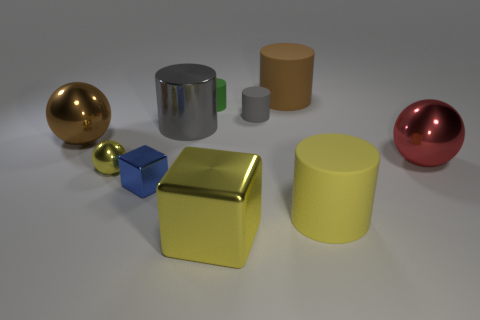Is the number of yellow metallic blocks that are to the left of the tiny yellow sphere greater than the number of brown objects that are behind the gray shiny cylinder?
Provide a short and direct response. No. Does the big gray cylinder have the same material as the large yellow cylinder?
Your answer should be very brief. No. There is a tiny rubber object on the right side of the large block; what number of gray rubber things are left of it?
Your answer should be very brief. 0. Do the large matte object behind the large metallic cylinder and the tiny sphere have the same color?
Your response must be concise. No. What number of things are either red objects or big objects that are right of the big brown metallic ball?
Offer a very short reply. 5. Do the thing that is behind the green rubber object and the big metal object that is in front of the yellow shiny ball have the same shape?
Your response must be concise. No. Is there anything else that is the same color as the small cube?
Give a very brief answer. No. What shape is the brown thing that is the same material as the green thing?
Provide a succinct answer. Cylinder. What is the cylinder that is both right of the tiny gray matte cylinder and in front of the big brown rubber thing made of?
Provide a short and direct response. Rubber. Is the color of the shiny cylinder the same as the big block?
Provide a short and direct response. No. 